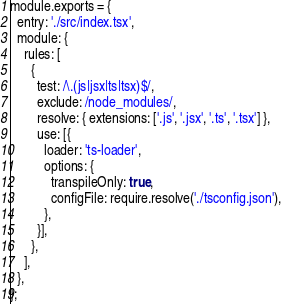Convert code to text. <code><loc_0><loc_0><loc_500><loc_500><_JavaScript_>module.exports = {
  entry: './src/index.tsx',
  module: {
    rules: [
      {
        test: /\.(js|jsx|ts|tsx)$/,
        exclude: /node_modules/,
        resolve: { extensions: ['.js', '.jsx', '.ts', '.tsx'] },
        use: [{
          loader: 'ts-loader',
          options: {
            transpileOnly: true,
            configFile: require.resolve('./tsconfig.json'),
          },
        }],
      },
    ],
  },
};
</code> 